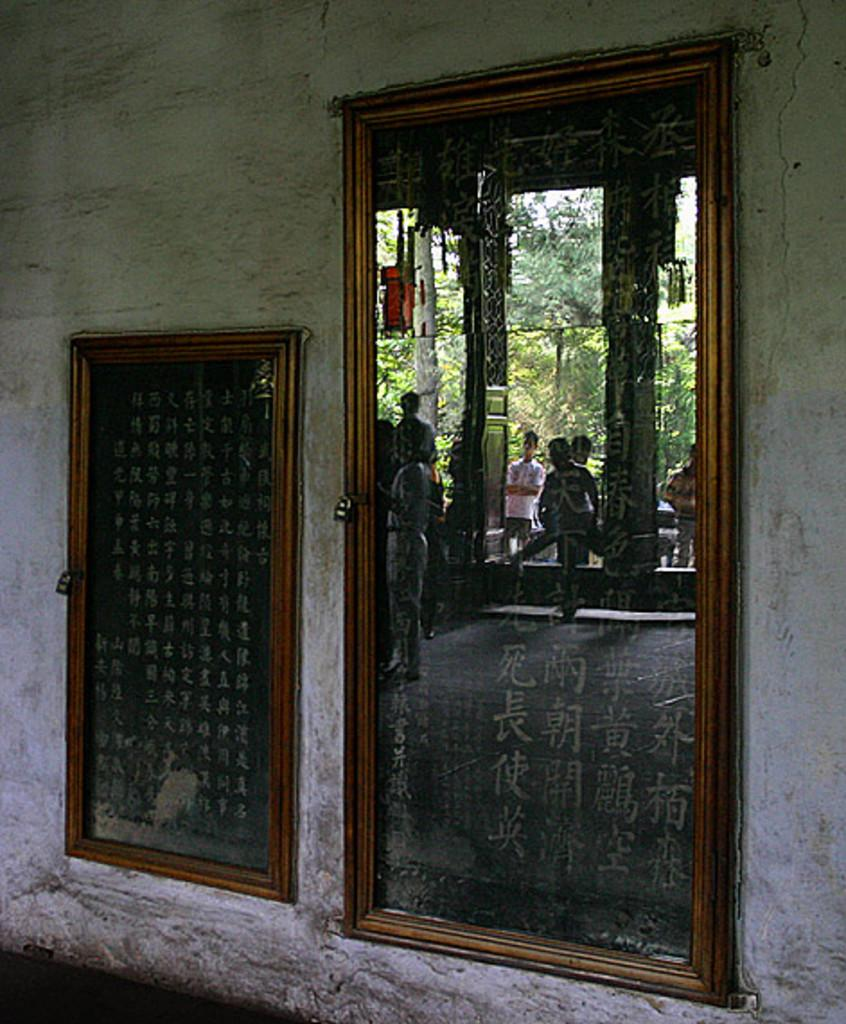What is on the wall in the image? There are boards on the wall. What do the boards depict? The boards depict persons and trees. Can you see any squirrels interacting with the trees on the boards? There are no squirrels present in the image; the boards depict persons and trees. What type of hair is visible on the persons depicted on the boards? There is no hair visible on the persons depicted on the boards, as they are likely two-dimensional images. 